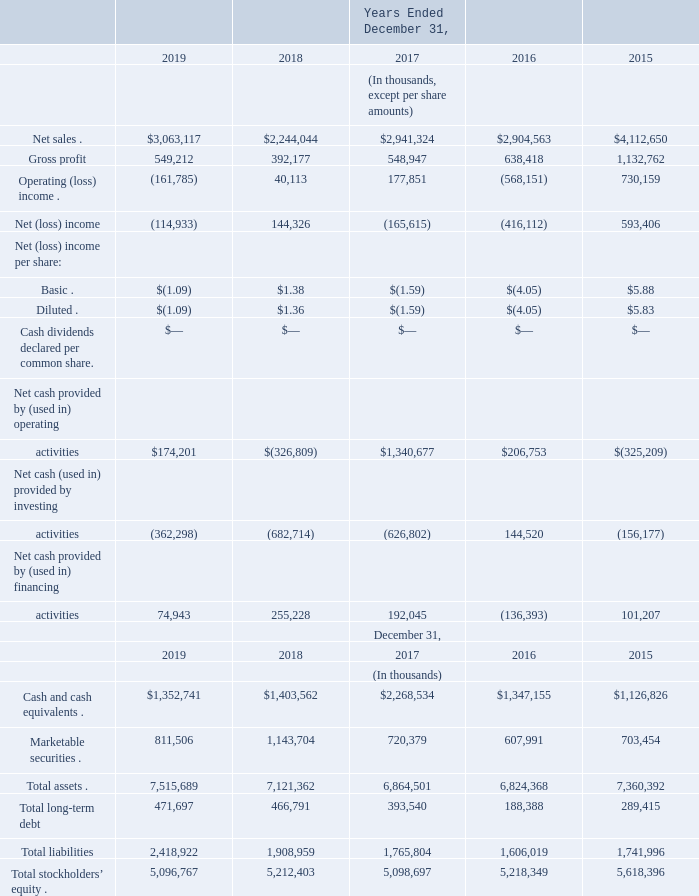Item 6. Selected Financial Data
The following tables set forth our selected financial data for the periods and at the dates indicated. The selected financial data from the consolidated statements of operations and consolidated statements of cash flows for the years ended December 31, 2019, 2018, and 2017 and the selected financial data from the consolidated balance sheets as of December 31, 2019 and 2018 have been derived from the audited consolidated financial statements included in this Annual Report on Form 10-K. The selected financial data from the consolidated statements of operations and consolidated statements of cash flows for the years ended December 31, 2016 and 2015 and the selected financial data from the consolidated balance sheets as of December 31, 2017, 2016, and 2015 have been derived from audited consolidated financial statements not included in this Annual Report on Form 10-K. The information presented below should also be read in conjunction with our consolidated financial statements and the related notes thereto and Item 7. “Management’s Discussion and Analysis of Financial Condition and Results of Operations.”
What was the net income per basic share in 2018? $1.38. What was the net cash provided by (used in) operating activities in 2018 and 2019 respectively?
Answer scale should be: thousand. $(326,809), $174,201. What was the amount of marketable securities in 2019?
Answer scale should be: thousand. 811,506. What is the change in total shareholders' equity from 2018 to 2019?
Answer scale should be: percent. (5,096,767 - 5,212,403) / 5,212,403 
Answer: -2.22. What is the difference between Net (loss) income in 2018 and 2019?
Answer scale should be: thousand. 144,326 - (-114,933) 
Answer: 259259. What was the percentage increase in gross profit from 2018 to 2019?
Answer scale should be: percent. (549,212 - 392,177) / 392,177 
Answer: 40.04. 